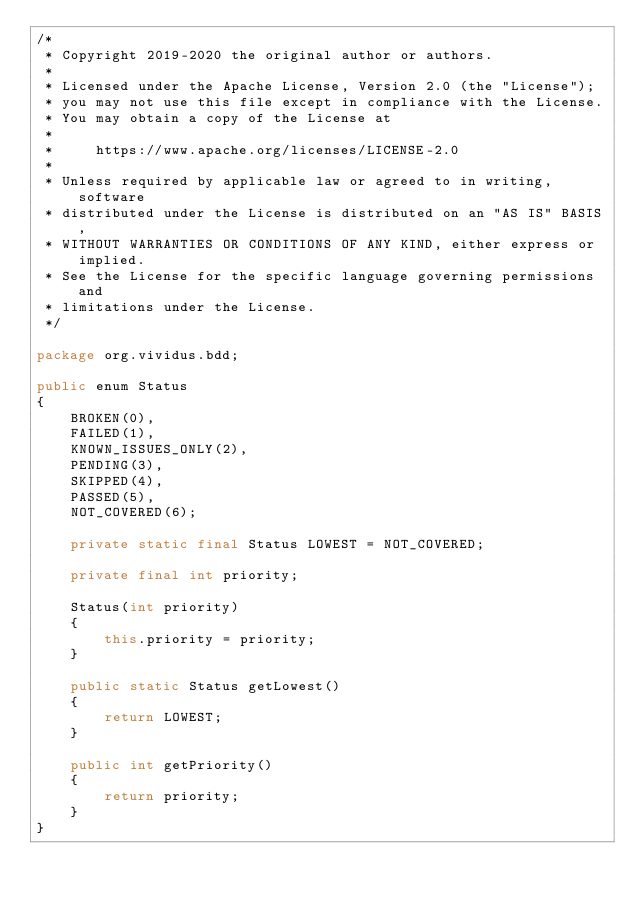Convert code to text. <code><loc_0><loc_0><loc_500><loc_500><_Java_>/*
 * Copyright 2019-2020 the original author or authors.
 *
 * Licensed under the Apache License, Version 2.0 (the "License");
 * you may not use this file except in compliance with the License.
 * You may obtain a copy of the License at
 *
 *     https://www.apache.org/licenses/LICENSE-2.0
 *
 * Unless required by applicable law or agreed to in writing, software
 * distributed under the License is distributed on an "AS IS" BASIS,
 * WITHOUT WARRANTIES OR CONDITIONS OF ANY KIND, either express or implied.
 * See the License for the specific language governing permissions and
 * limitations under the License.
 */

package org.vividus.bdd;

public enum Status
{
    BROKEN(0),
    FAILED(1),
    KNOWN_ISSUES_ONLY(2),
    PENDING(3),
    SKIPPED(4),
    PASSED(5),
    NOT_COVERED(6);

    private static final Status LOWEST = NOT_COVERED;

    private final int priority;

    Status(int priority)
    {
        this.priority = priority;
    }

    public static Status getLowest()
    {
        return LOWEST;
    }

    public int getPriority()
    {
        return priority;
    }
}
</code> 